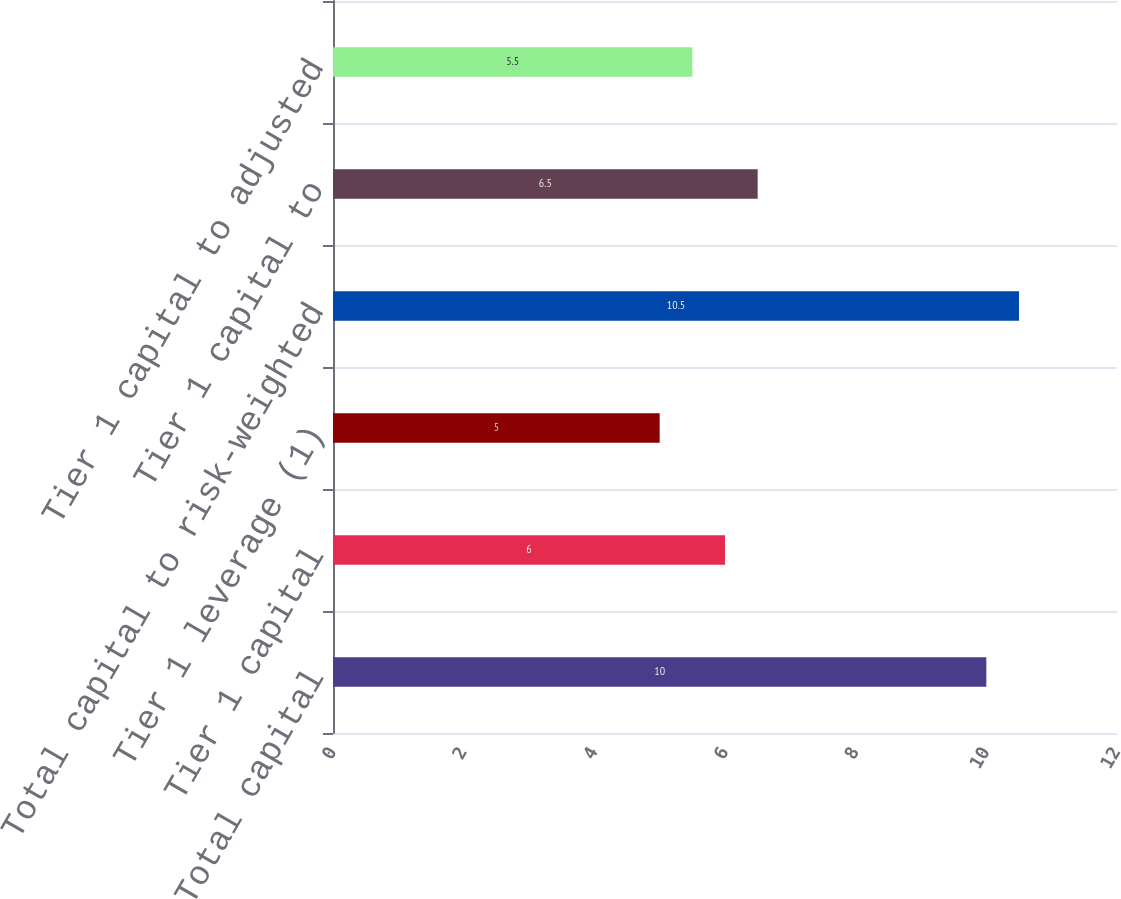Convert chart to OTSL. <chart><loc_0><loc_0><loc_500><loc_500><bar_chart><fcel>Total capital<fcel>Tier 1 capital<fcel>Tier 1 leverage (1)<fcel>Total capital to risk-weighted<fcel>Tier 1 capital to<fcel>Tier 1 capital to adjusted<nl><fcel>10<fcel>6<fcel>5<fcel>10.5<fcel>6.5<fcel>5.5<nl></chart> 